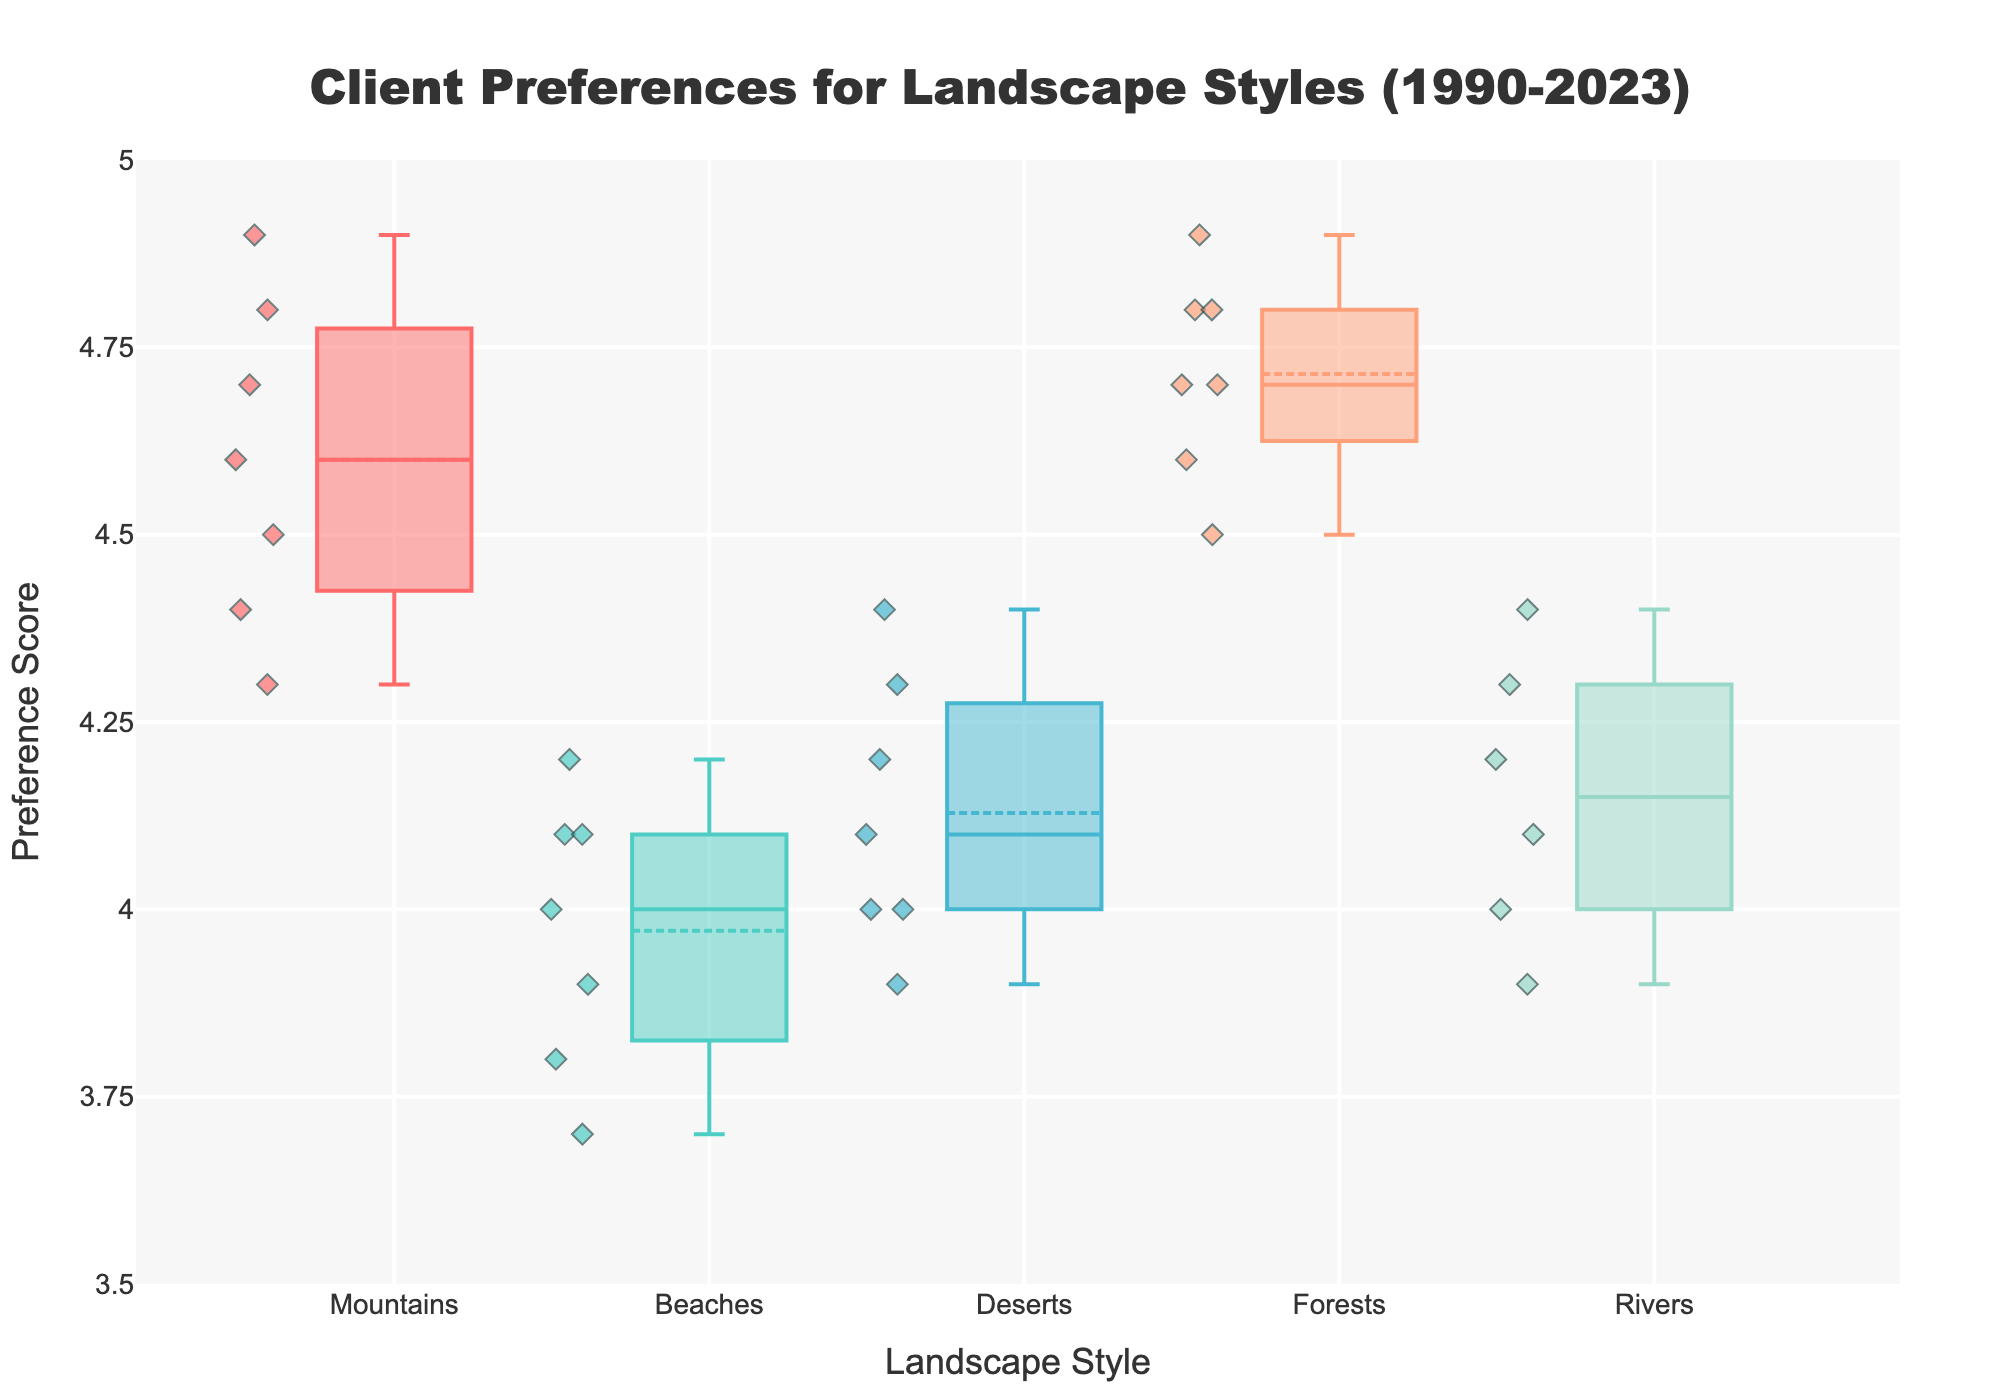How many different landscape styles are represented in the figure? Count the distinct categories on the x-axis which correspond to different styles.
Answer: Five styles Are there more data points before or after the year 2000? Count the data points in each category before and after 2000. There are 10 data points before 2000 (1990-1999) and 24 after (2000-2023).
Answer: After 2000 Which landscape style has the highest median Preference Score? Find the line inside each box in the box plots, which represents the median, and identify the highest one.
Answer: Forests What is the median Preference Score for Rivers? Observe the line inside the box plot for Rivers.
Answer: 4.1 Which style has the widest range in Preference Scores? Determine the range by looking at the whiskers (end lines) of each box plot and comparing them.
Answer: Mountains Between Mountains and Beaches, which style has a higher variability in Client Preference? Compare the interquartile range (IQR - the length of the box, from the first quartile to the third quartile) for both styles. Mountains have a wider box than Beaches.
Answer: Mountains What is the most common Preference Score range across all landscape styles? Identify the range overlap among the boxes and whiskers of all styles. Most styles frequently lie between 4.0 and 4.5.
Answer: 4.0 to 4.5 Which style has the lowest outlier Preference Score and what is it? Look for individual points that fall outside the whiskers for each style. Identify the lowest among them.
Answer: Beaches, 3.7 How does the average Preference Score of Beaches compare to that of Deserts? By observing the position of the mean marker inside the box plot (often a symbol like a triangle or dot). Compute or estimate visually their means. Beaches have a mean around 4.0, and Deserts have a mean slightly higher than 4.0.
Answer: Deserts are higher Which years have the highest and lowest Preference Scores for Forests? By identifying the scatter points for the Forests within the box plot and comparing their positions.
Answer: Highest: 2018 and 2023 (4.9), Lowest: 1998 (4.6) 